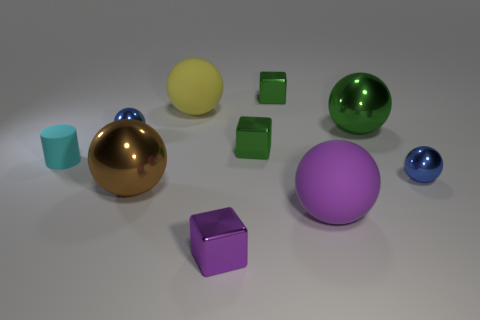What is the material of the large brown object that is the same shape as the big yellow matte object?
Your answer should be very brief. Metal. There is a blue object that is on the right side of the purple shiny cube; what number of small metallic cubes are behind it?
Offer a terse response. 2. What number of things are either brown rubber cylinders or small metallic balls in front of the cyan matte object?
Your answer should be compact. 1. There is a purple object that is on the right side of the cube behind the small blue sphere that is on the left side of the big purple ball; what is its material?
Offer a very short reply. Rubber. There is a purple sphere that is made of the same material as the yellow object; what size is it?
Give a very brief answer. Large. What is the color of the block that is in front of the large metallic ball that is in front of the matte cylinder?
Provide a short and direct response. Purple. How many small purple blocks are the same material as the large green object?
Offer a very short reply. 1. What number of rubber objects are tiny green spheres or small green cubes?
Provide a succinct answer. 0. There is a yellow sphere that is the same size as the purple rubber thing; what is it made of?
Offer a terse response. Rubber. Are there any red spheres that have the same material as the tiny cyan cylinder?
Provide a succinct answer. No. 